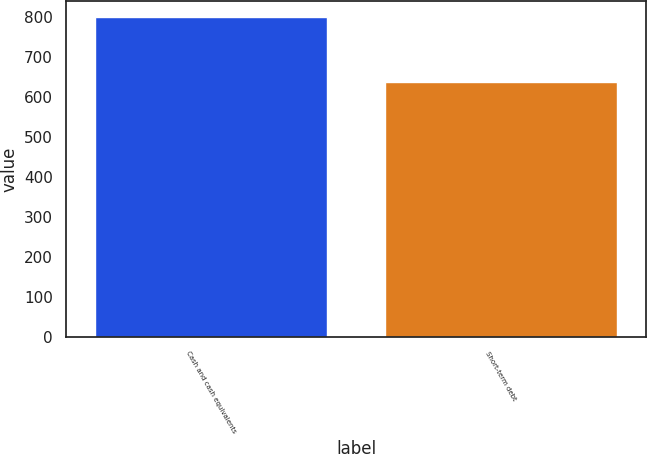Convert chart to OTSL. <chart><loc_0><loc_0><loc_500><loc_500><bar_chart><fcel>Cash and cash equivalents<fcel>Short-term debt<nl><fcel>801<fcel>639<nl></chart> 